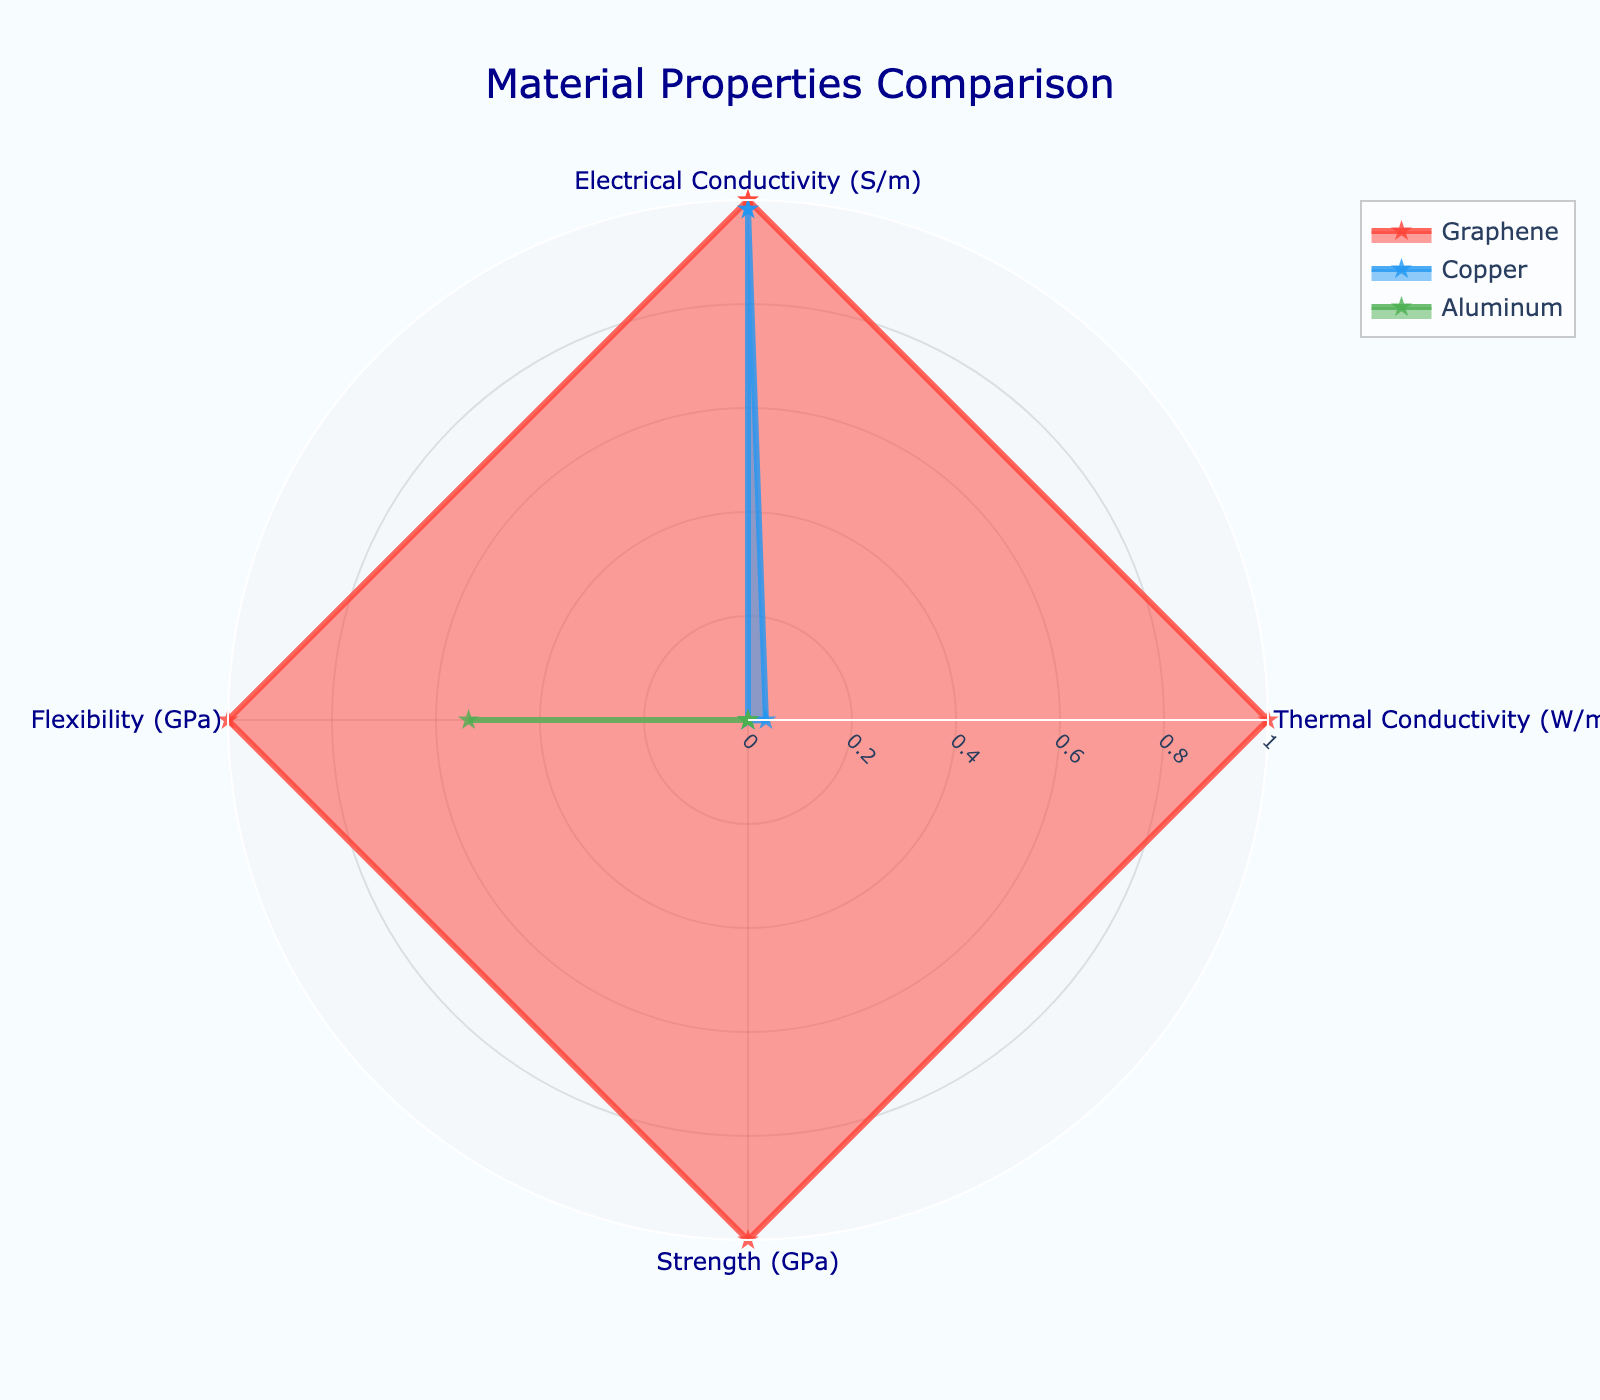What is the title of the radar chart? The title is located at the top of the radar chart, displaying the name of the figure. It reads "Material Properties Comparison".
Answer: Material Properties Comparison Which material has the highest thermal conductivity? By observing the thermal conductivity axis on the radar chart, we see that Graphene reaches significantly higher values on this metric compared to Copper and Aluminum.
Answer: Graphene Which material exhibits the greatest flexibility? Looking at the flexibility axis, we notice that Graphene has the highest value as its line extends the furthest in this direction compared to Copper and Aluminum.
Answer: Graphene How do the electrical conductivities of Copper and Aluminum compare? On the electrical conductivity axis, Copper's value is higher than Aluminum's. This comparison is evident as Copper's plot is closer to the maximum extent on the axis.
Answer: Copper's electrical conductivity is higher than Aluminum's What property has the least variation among the materials? By evaluating the range of values across all axes, it's clear that electrical conductivity shows the least variation, with all materials having relatively high values concentrated around the same area.
Answer: Electrical Conductivity Which material shows a unique combination of high strength and flexibility? Graphene stands out by having high values for both strength and flexibility, as observed along these axes where Graphene's plot extends furthest.
Answer: Graphene For which property do all three materials have normalized values close to each other? Observing all axes, we note that the flexibility axis shows the normalized values of the materials clustering near each other, indicating similar flexibility values.
Answer: Flexibility How does aluminum compare in terms of strength and thermal conductivity? Analyzing the radar chart, Aluminum lies significantly lower on the strength axis but is also relatively low on the thermal conductivity axis compared to Copper and Graphene.
Answer: Aluminum has lower strength and lower thermal conductivity compared to the others Which property(s) of Copper and Graphene display the most divergence? The thermal conductivity axis shows a significant divergence, where Graphene's value far exceeds Copper's, making it the most distinct difference between the two materials.
Answer: Thermal Conductivity What combination of properties makes Graphene superior for diverse applications? Graphene exhibits superior qualities in electrical conductivity, thermal conductivity, strength, and flexibility. Its plot extends vastly along all axes, making it highly versatile.
Answer: High values in all properties 